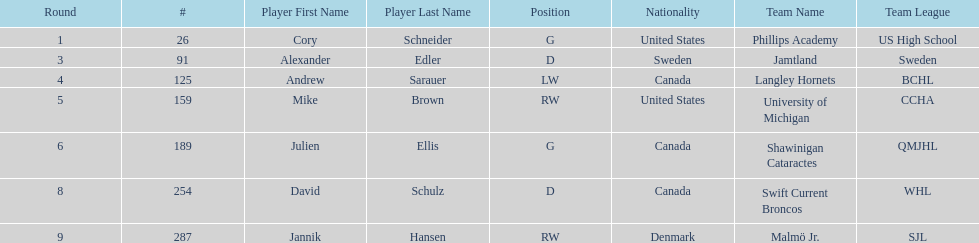How many goalies drafted? 2. 